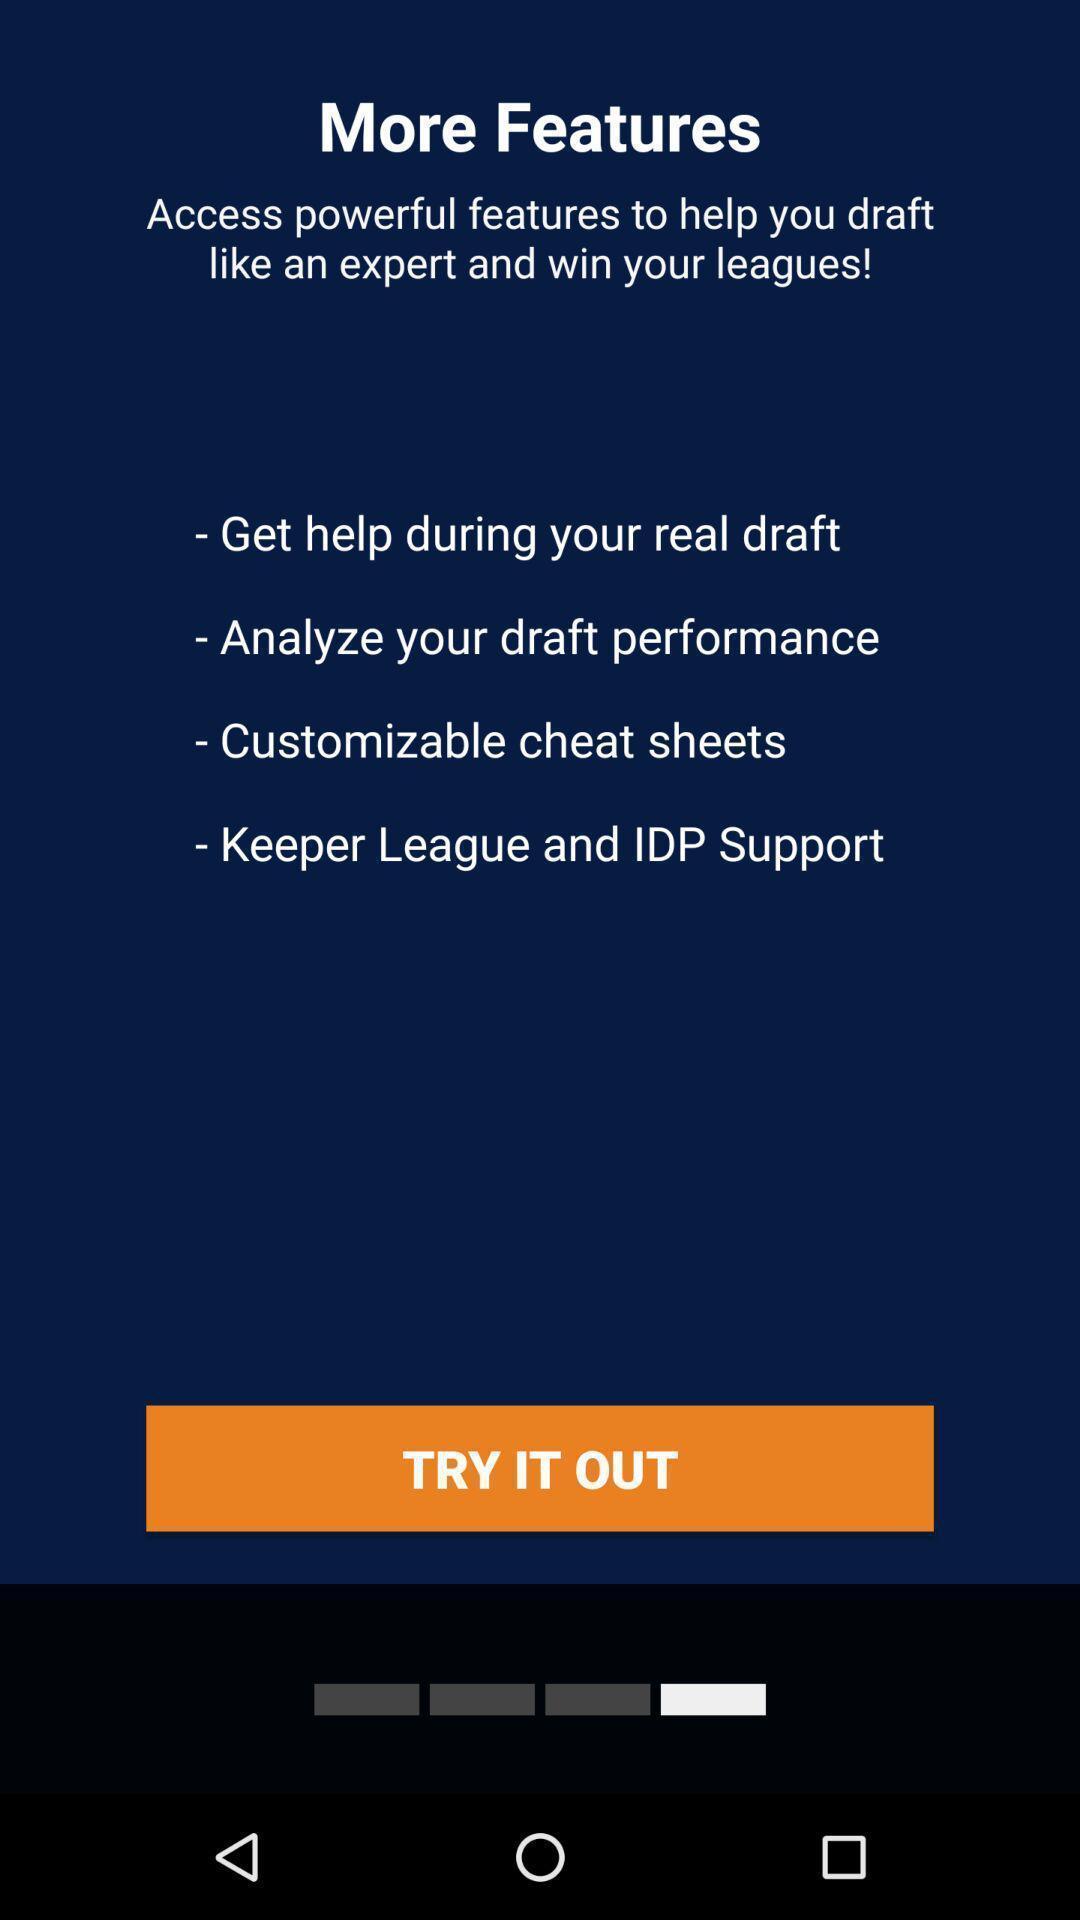Please provide a description for this image. Screen displaying features information. 